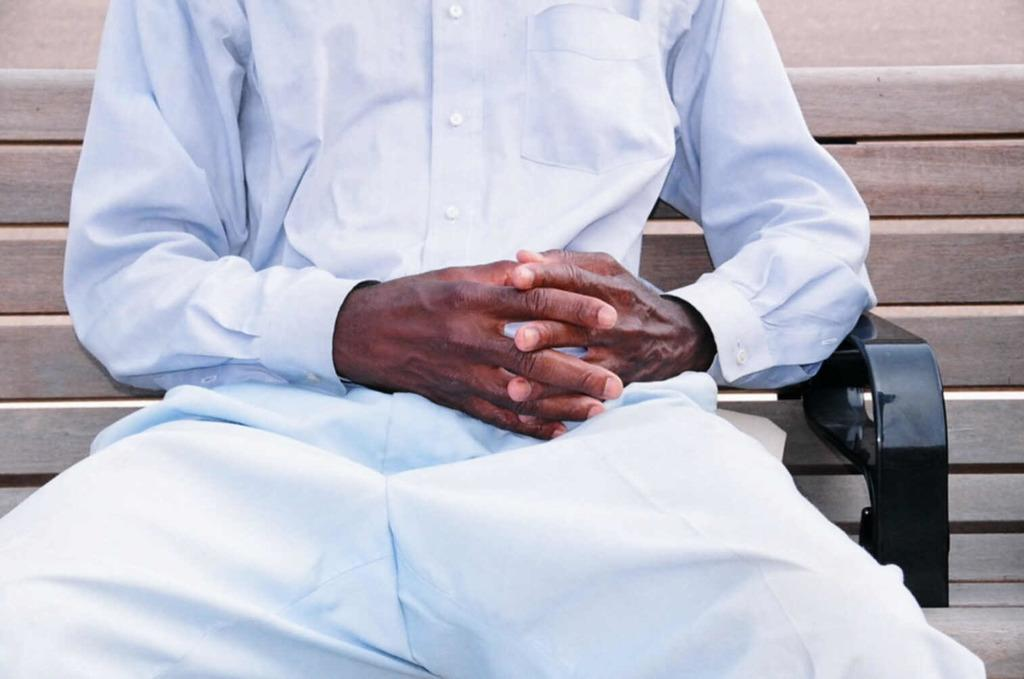Who or what can be seen in the image? There is a person in the image. What is the person doing in the image? The person is sitting on a bench. What type of brass instrument is the person playing in the image? There is no brass instrument present in the image; the person is simply sitting on a bench. 